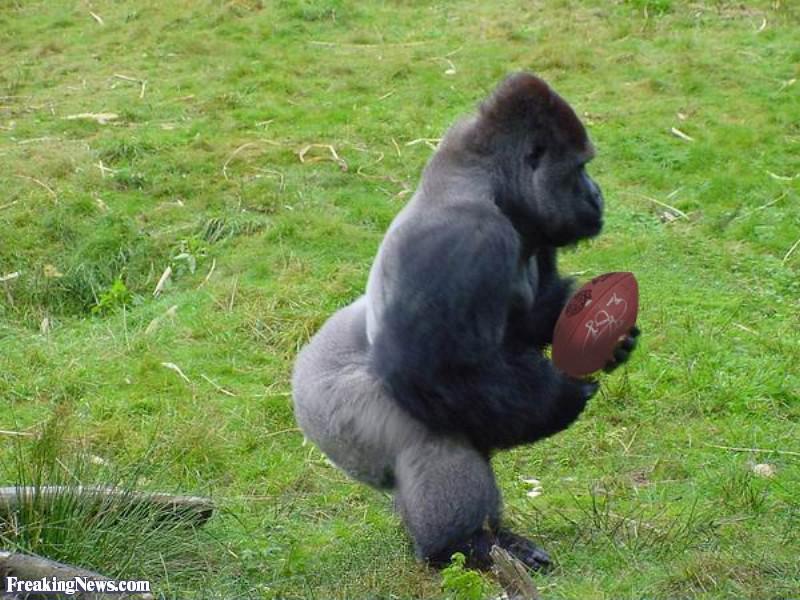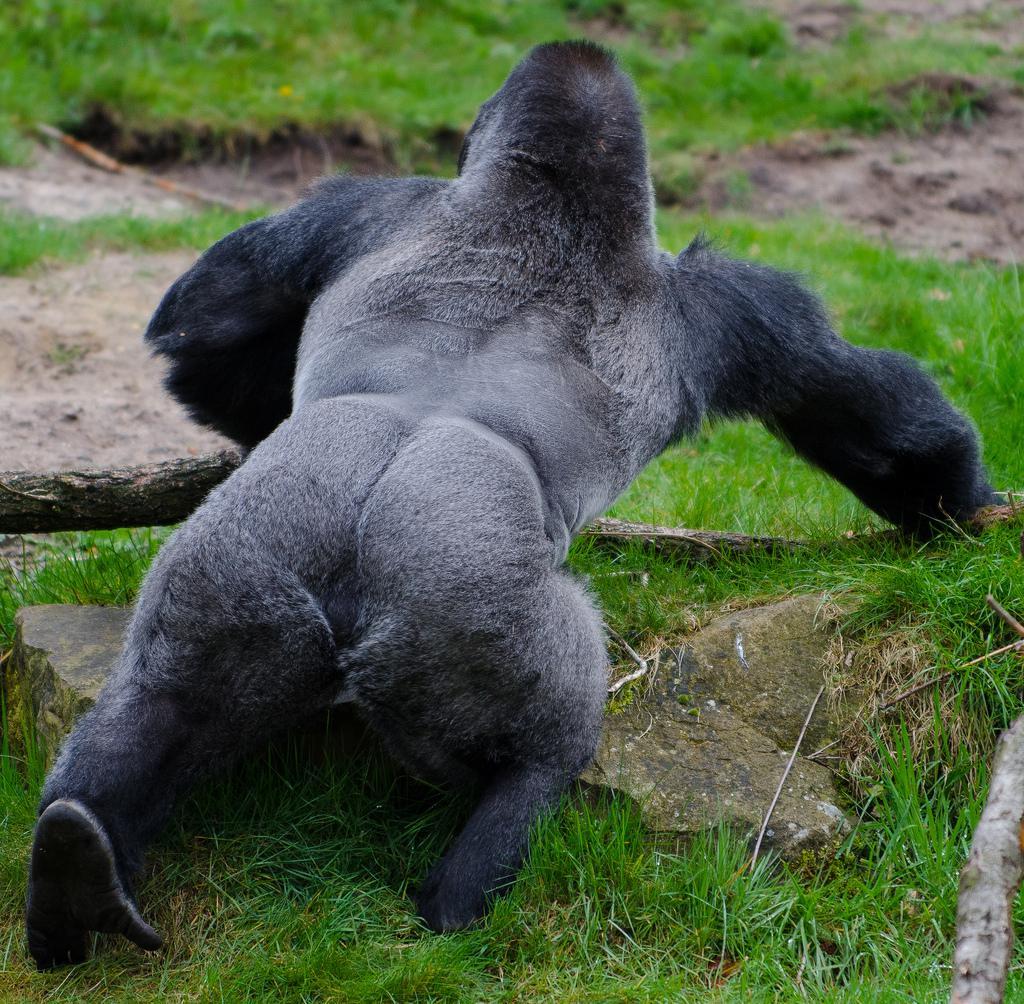The first image is the image on the left, the second image is the image on the right. Assess this claim about the two images: "One of the images contains two gorillas that are fighting.". Correct or not? Answer yes or no. No. 